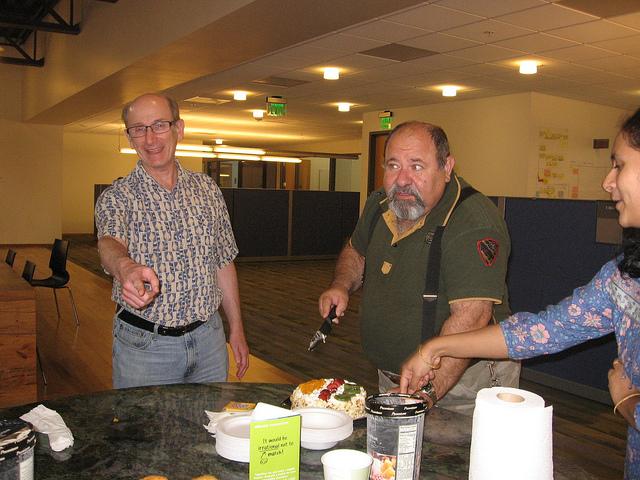Are there any women in the photo?
Concise answer only. Yes. Are there people eating?
Write a very short answer. Yes. How many people are in the pic?
Give a very brief answer. 3. What room is this?
Be succinct. Office. 